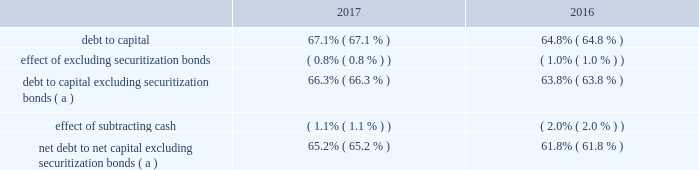Operations may be extended up to four additional years for each unit by mutual agreement of entergy and new york state based on an exigent reliability need for indian point generation .
In accordance with the ferc-approved tariff of the new york independent system operator ( nyiso ) , entergy submitted to the nyiso a notice of generator deactivation based on the dates in the settlement ( no later than april 30 , 2020 for indian point unit 2 and april 30 , 2021 for indian point unit 3 ) .
In december 2017 , nyiso issued a report stating there will not be a system reliability need following the deactivation of indian point .
The nyiso also has advised that it will perform an analysis of the potential competitive impacts of the proposed retirement under provisions of its tariff .
The deadline for the nyiso to make a withholding determination is in dispute and is pending before the ferc .
In addition to contractually agreeing to cease commercial operations early , in february 2017 entergy filed with the nrc an amendment to its license renewal application changing the term of the requested licenses to coincide with the latest possible extension by mutual agreement based on exigent reliability needs : april 30 , 2024 for indian point 2 and april 30 , 2025 for indian point 3 .
If entergy reasonably determines that the nrc will treat the amendment other than as a routine amendment , entergy may withdraw the amendment .
Other provisions of the settlement include termination of all then-existing investigations of indian point by the agencies signing the agreement , which include the new york state department of environmental conservation , the new york state department of state , the new york state department of public service , the new york state department of health , and the new york state attorney general .
The settlement recognizes the right of new york state agencies to pursue new investigations and enforcement actions with respect to new circumstances or existing conditions that become materially exacerbated .
Another provision of the settlement obligates entergy to establish a $ 15 million fund for environmental projects and community support .
Apportionment and allocation of funds to beneficiaries are to be determined by mutual agreement of new york state and entergy .
The settlement recognizes new york state 2019s right to perform an annual inspection of indian point , with scope and timing to be determined by mutual agreement .
In may 2017 a plaintiff filed two parallel state court appeals challenging new york state 2019s actions in signing and implementing the indian point settlement with entergy on the basis that the state failed to perform sufficient environmental analysis of its actions .
All signatories to the settlement agreement , including the entergy affiliates that hold nrc licenses for indian point , were named .
The appeals were voluntarily dismissed in november 2017 .
Entergy corporation and subsidiaries management 2019s financial discussion and analysis liquidity and capital resources this section discusses entergy 2019s capital structure , capital spending plans and other uses of capital , sources of capital , and the cash flow activity presented in the cash flow statement .
Capital structure entergy 2019s capitalization is balanced between equity and debt , as shown in the table .
The increase in the debt to capital ratio for entergy as of december 31 , 2017 is primarily due to an increase in commercial paper outstanding in 2017 as compared to 2016. .
( a ) calculation excludes the arkansas , louisiana , new orleans , and texas securitization bonds , which are non- recourse to entergy arkansas , entergy louisiana , entergy new orleans , and entergy texas , respectively. .
What is the percent change in debt to capital from 2016 to 2017? 
Computations: ((67.1 - 64.8) / 64.8)
Answer: 0.03549. 